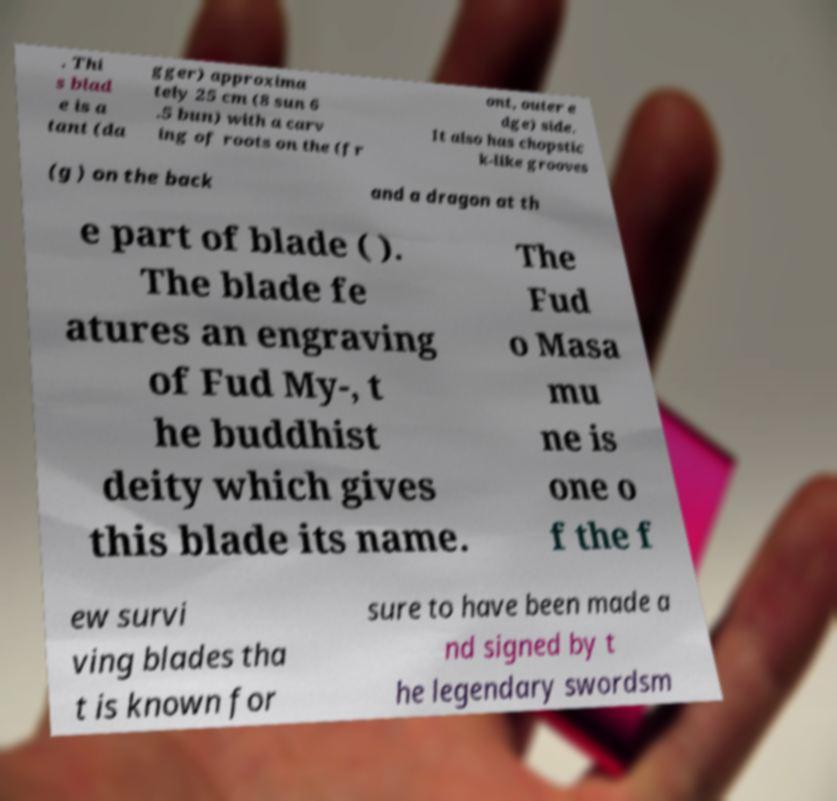There's text embedded in this image that I need extracted. Can you transcribe it verbatim? . Thi s blad e is a tant (da gger) approxima tely 25 cm (8 sun 6 .5 bun) with a carv ing of roots on the (fr ont, outer e dge) side. It also has chopstic k-like grooves (g ) on the back and a dragon at th e part of blade ( ). The blade fe atures an engraving of Fud My-, t he buddhist deity which gives this blade its name. The Fud o Masa mu ne is one o f the f ew survi ving blades tha t is known for sure to have been made a nd signed by t he legendary swordsm 